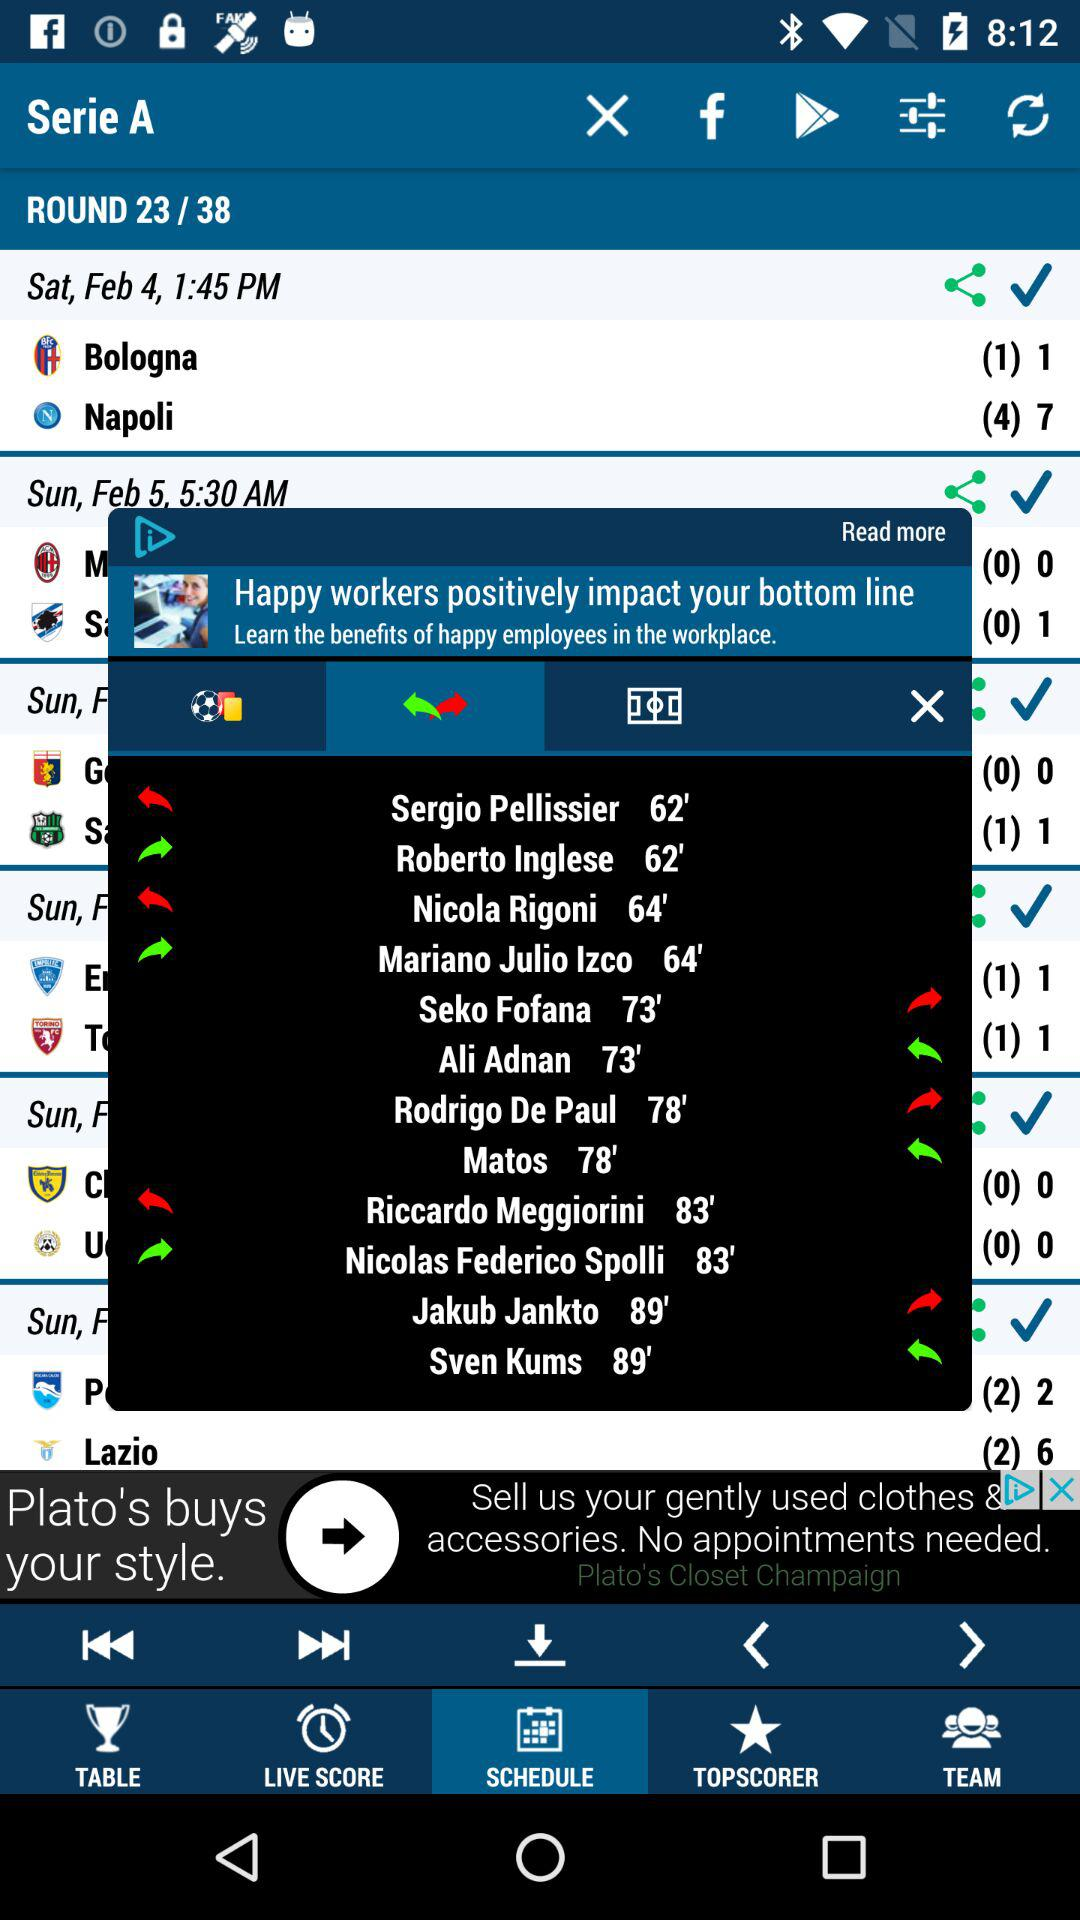On which date was the match between "Bologna" and "Napoli" played? The match between "Bologna" and "Napoli" was played on Saturday, February 4, at 1:45 p.m. 